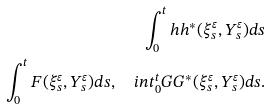Convert formula to latex. <formula><loc_0><loc_0><loc_500><loc_500>\int _ { 0 } ^ { t } h h ^ { * } ( \xi ^ { \varepsilon } _ { s } , Y ^ { \varepsilon } _ { s } ) d s \\ \int _ { 0 } ^ { t } F ( \xi ^ { \varepsilon } _ { s } , Y ^ { \varepsilon } _ { s } ) d s , \quad i n t _ { 0 } ^ { t } G G ^ { * } ( \xi ^ { \varepsilon } _ { s } , Y ^ { \varepsilon } _ { s } ) d s .</formula> 